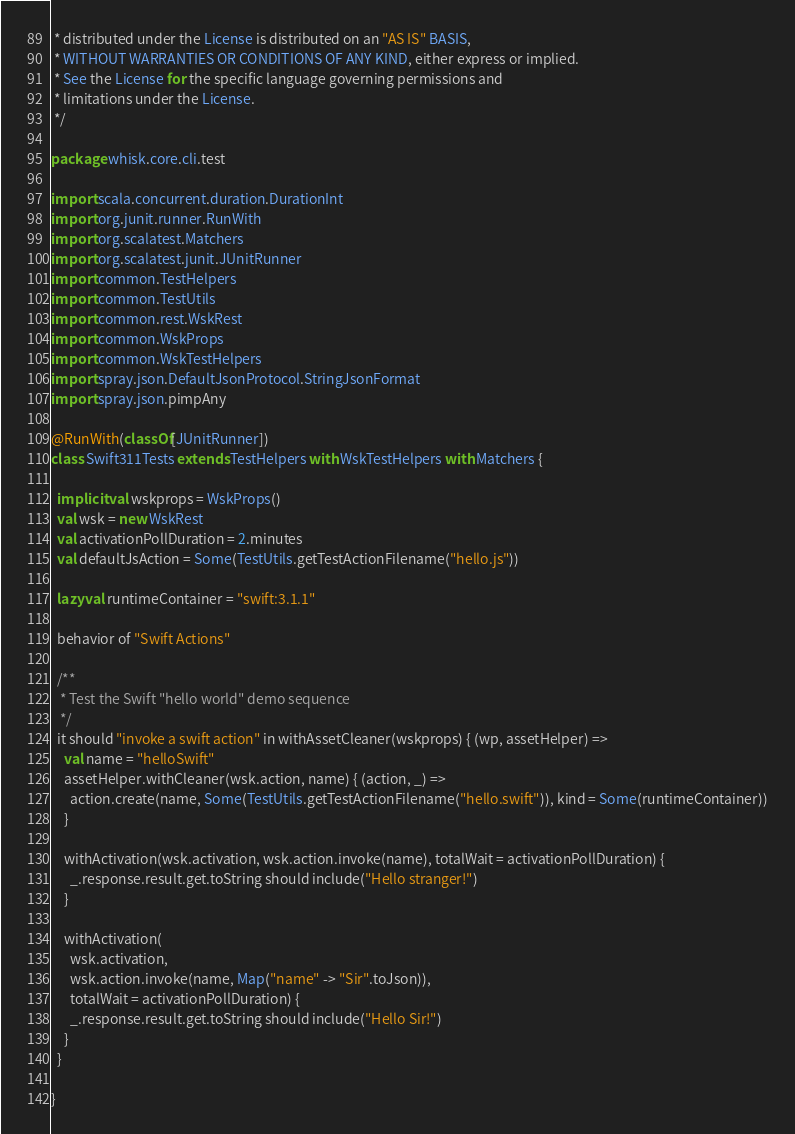Convert code to text. <code><loc_0><loc_0><loc_500><loc_500><_Scala_> * distributed under the License is distributed on an "AS IS" BASIS,
 * WITHOUT WARRANTIES OR CONDITIONS OF ANY KIND, either express or implied.
 * See the License for the specific language governing permissions and
 * limitations under the License.
 */

package whisk.core.cli.test

import scala.concurrent.duration.DurationInt
import org.junit.runner.RunWith
import org.scalatest.Matchers
import org.scalatest.junit.JUnitRunner
import common.TestHelpers
import common.TestUtils
import common.rest.WskRest
import common.WskProps
import common.WskTestHelpers
import spray.json.DefaultJsonProtocol.StringJsonFormat
import spray.json.pimpAny

@RunWith(classOf[JUnitRunner])
class Swift311Tests extends TestHelpers with WskTestHelpers with Matchers {

  implicit val wskprops = WskProps()
  val wsk = new WskRest
  val activationPollDuration = 2.minutes
  val defaultJsAction = Some(TestUtils.getTestActionFilename("hello.js"))

  lazy val runtimeContainer = "swift:3.1.1"

  behavior of "Swift Actions"

  /**
   * Test the Swift "hello world" demo sequence
   */
  it should "invoke a swift action" in withAssetCleaner(wskprops) { (wp, assetHelper) =>
    val name = "helloSwift"
    assetHelper.withCleaner(wsk.action, name) { (action, _) =>
      action.create(name, Some(TestUtils.getTestActionFilename("hello.swift")), kind = Some(runtimeContainer))
    }

    withActivation(wsk.activation, wsk.action.invoke(name), totalWait = activationPollDuration) {
      _.response.result.get.toString should include("Hello stranger!")
    }

    withActivation(
      wsk.activation,
      wsk.action.invoke(name, Map("name" -> "Sir".toJson)),
      totalWait = activationPollDuration) {
      _.response.result.get.toString should include("Hello Sir!")
    }
  }

}
</code> 